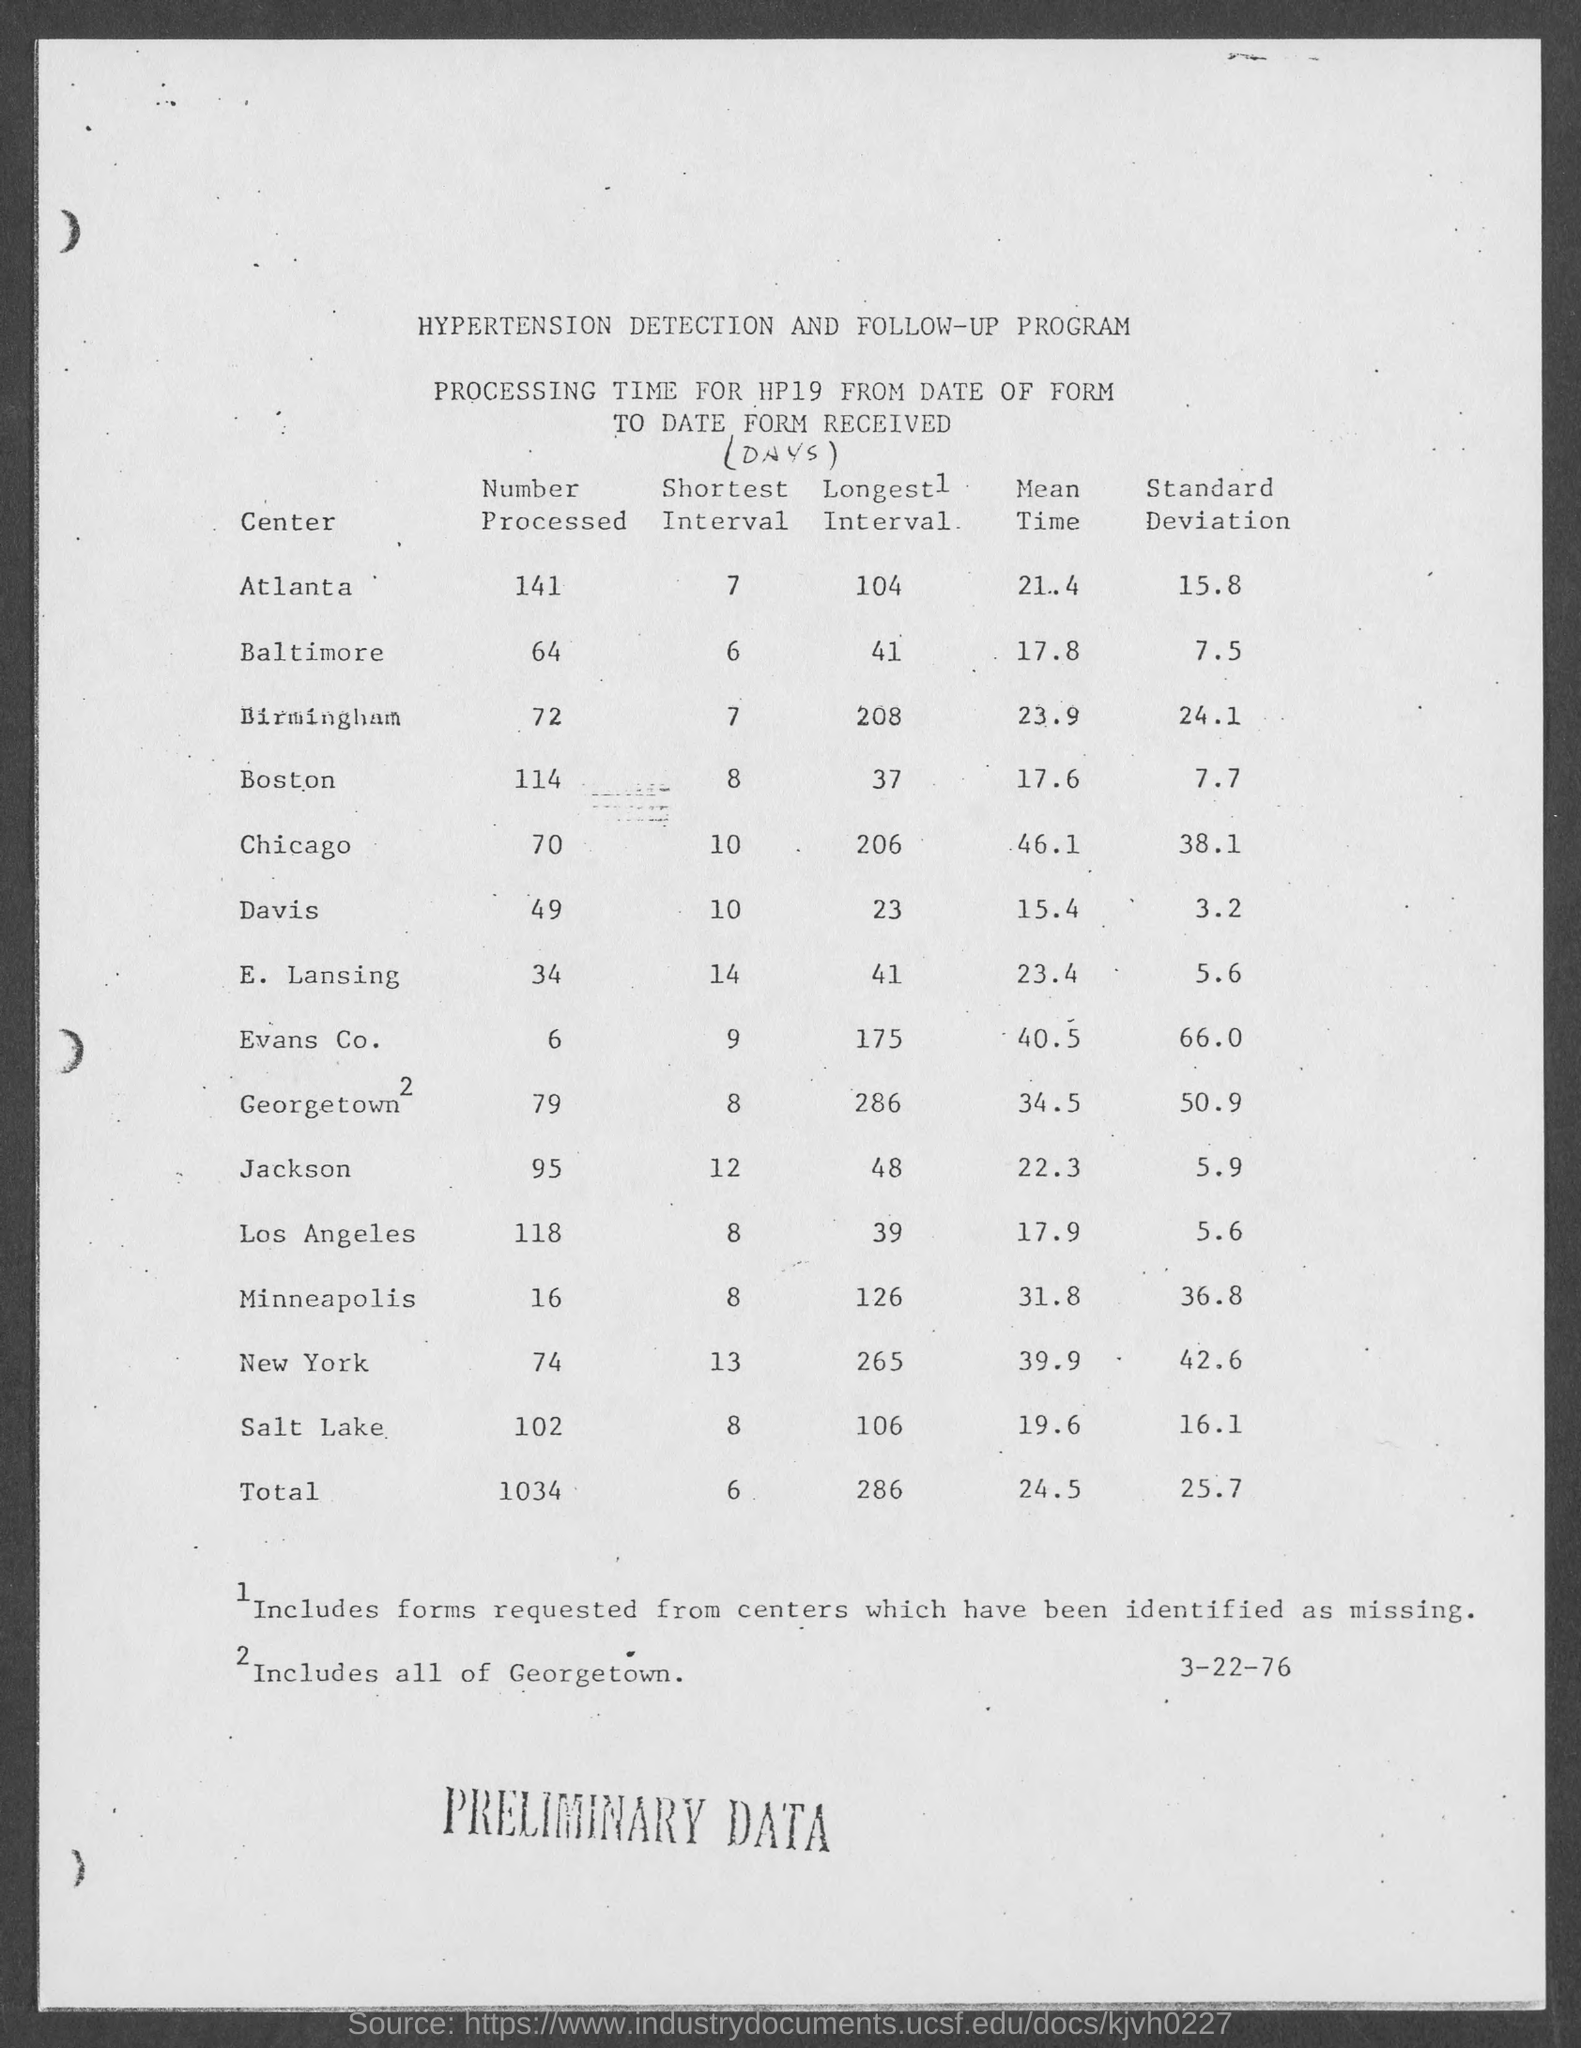Draw attention to some important aspects in this diagram. The standard deviation for Baltimore is 7.5. The mean time for Atlanta is 21.4. The number processed for Baltimore is 64. The title of the program is the Hypertension Detection and Follow-up Program. The standard deviation for Atlanta is 15.8," indicating that the degree of variation or spread of the data in Atlanta is 15.8. 